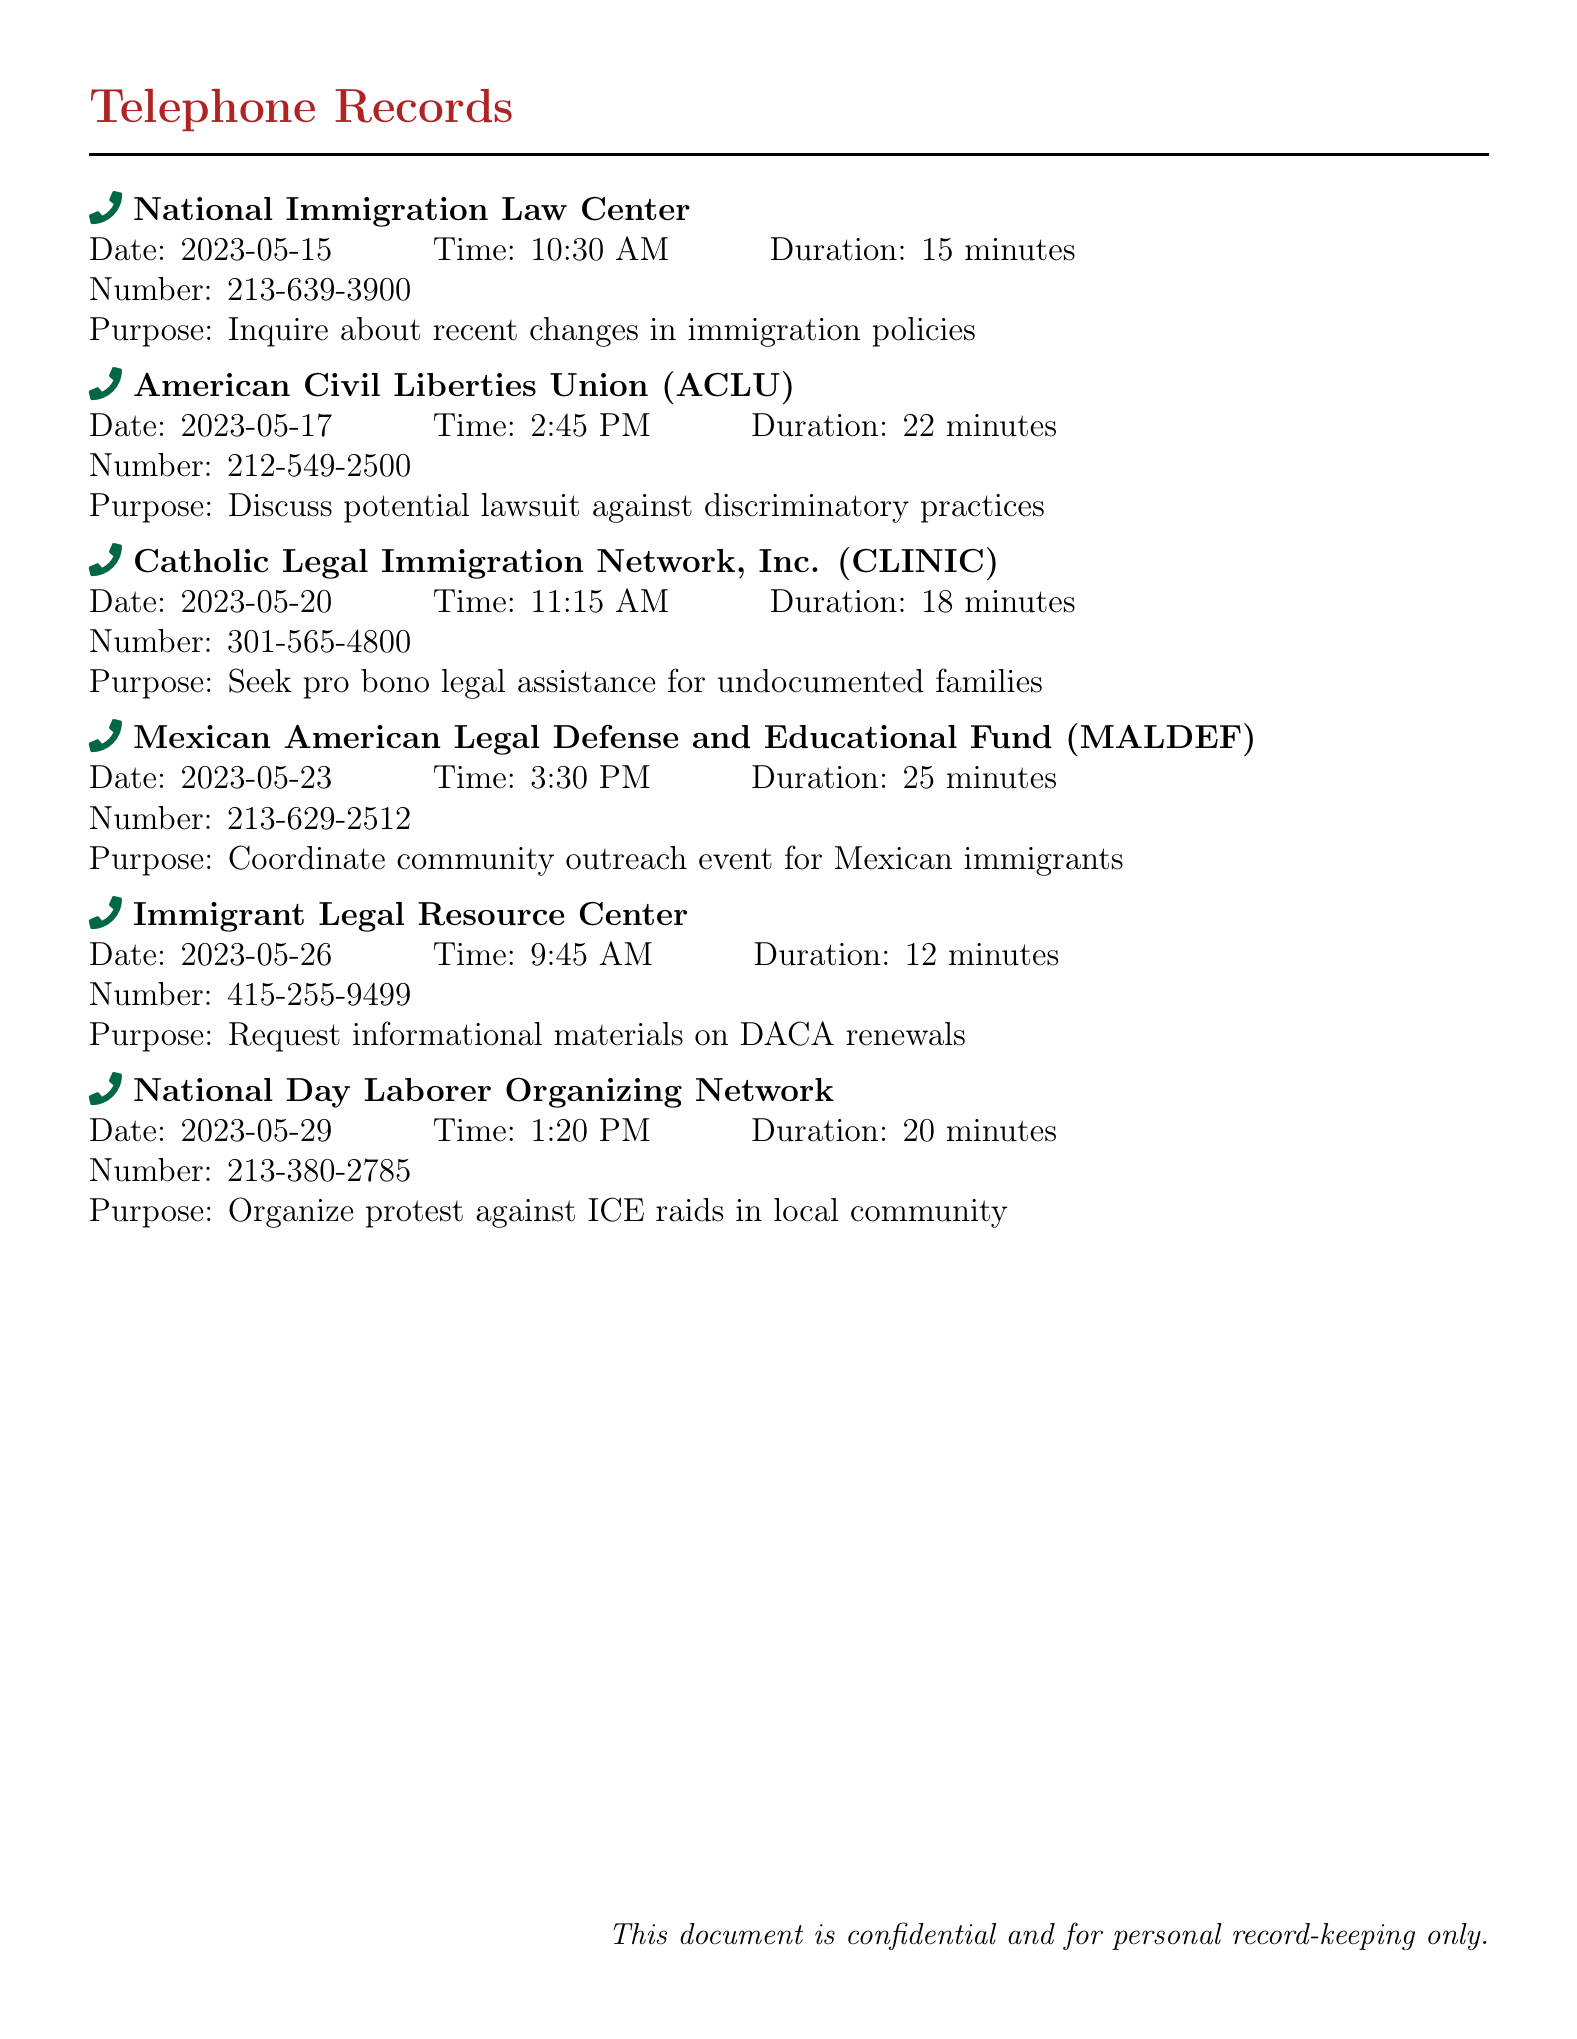what is the purpose of the call to National Immigration Law Center? The purpose of the call is to inquire about recent changes in immigration policies.
Answer: Inquire about recent changes in immigration policies what was the duration of the call to the American Civil Liberties Union? The duration of the call was 22 minutes.
Answer: 22 minutes who did the call on May 23 involve? The call involved the Mexican American Legal Defense and Educational Fund (MALDEF).
Answer: Mexican American Legal Defense and Educational Fund (MALDEF) how many different organizations were called in total? There are six different organizations listed in the records.
Answer: 6 what was the name of the organization that provided pro bono legal assistance? The organization is Catholic Legal Immigration Network, Inc. (CLINIC).
Answer: Catholic Legal Immigration Network, Inc. (CLINIC) what is the phone number for the Immigrant Legal Resource Center? The phone number is 415-255-9499.
Answer: 415-255-9499 which organization was contacted regarding a protest? The organization contacted was the National Day Laborer Organizing Network.
Answer: National Day Laborer Organizing Network on what date was the call to coordinate a community outreach event made? The call was made on May 23.
Answer: May 23 what time was the call to the Catholic Legal Immigration Network made? The call was made at 11:15 AM.
Answer: 11:15 AM 